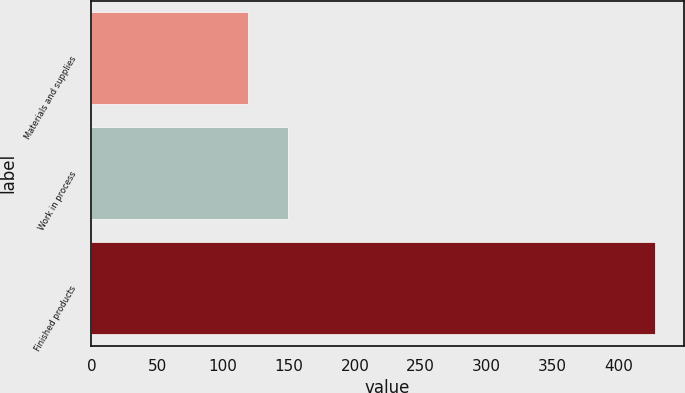<chart> <loc_0><loc_0><loc_500><loc_500><bar_chart><fcel>Materials and supplies<fcel>Work in process<fcel>Finished products<nl><fcel>118.5<fcel>149.46<fcel>428.1<nl></chart> 